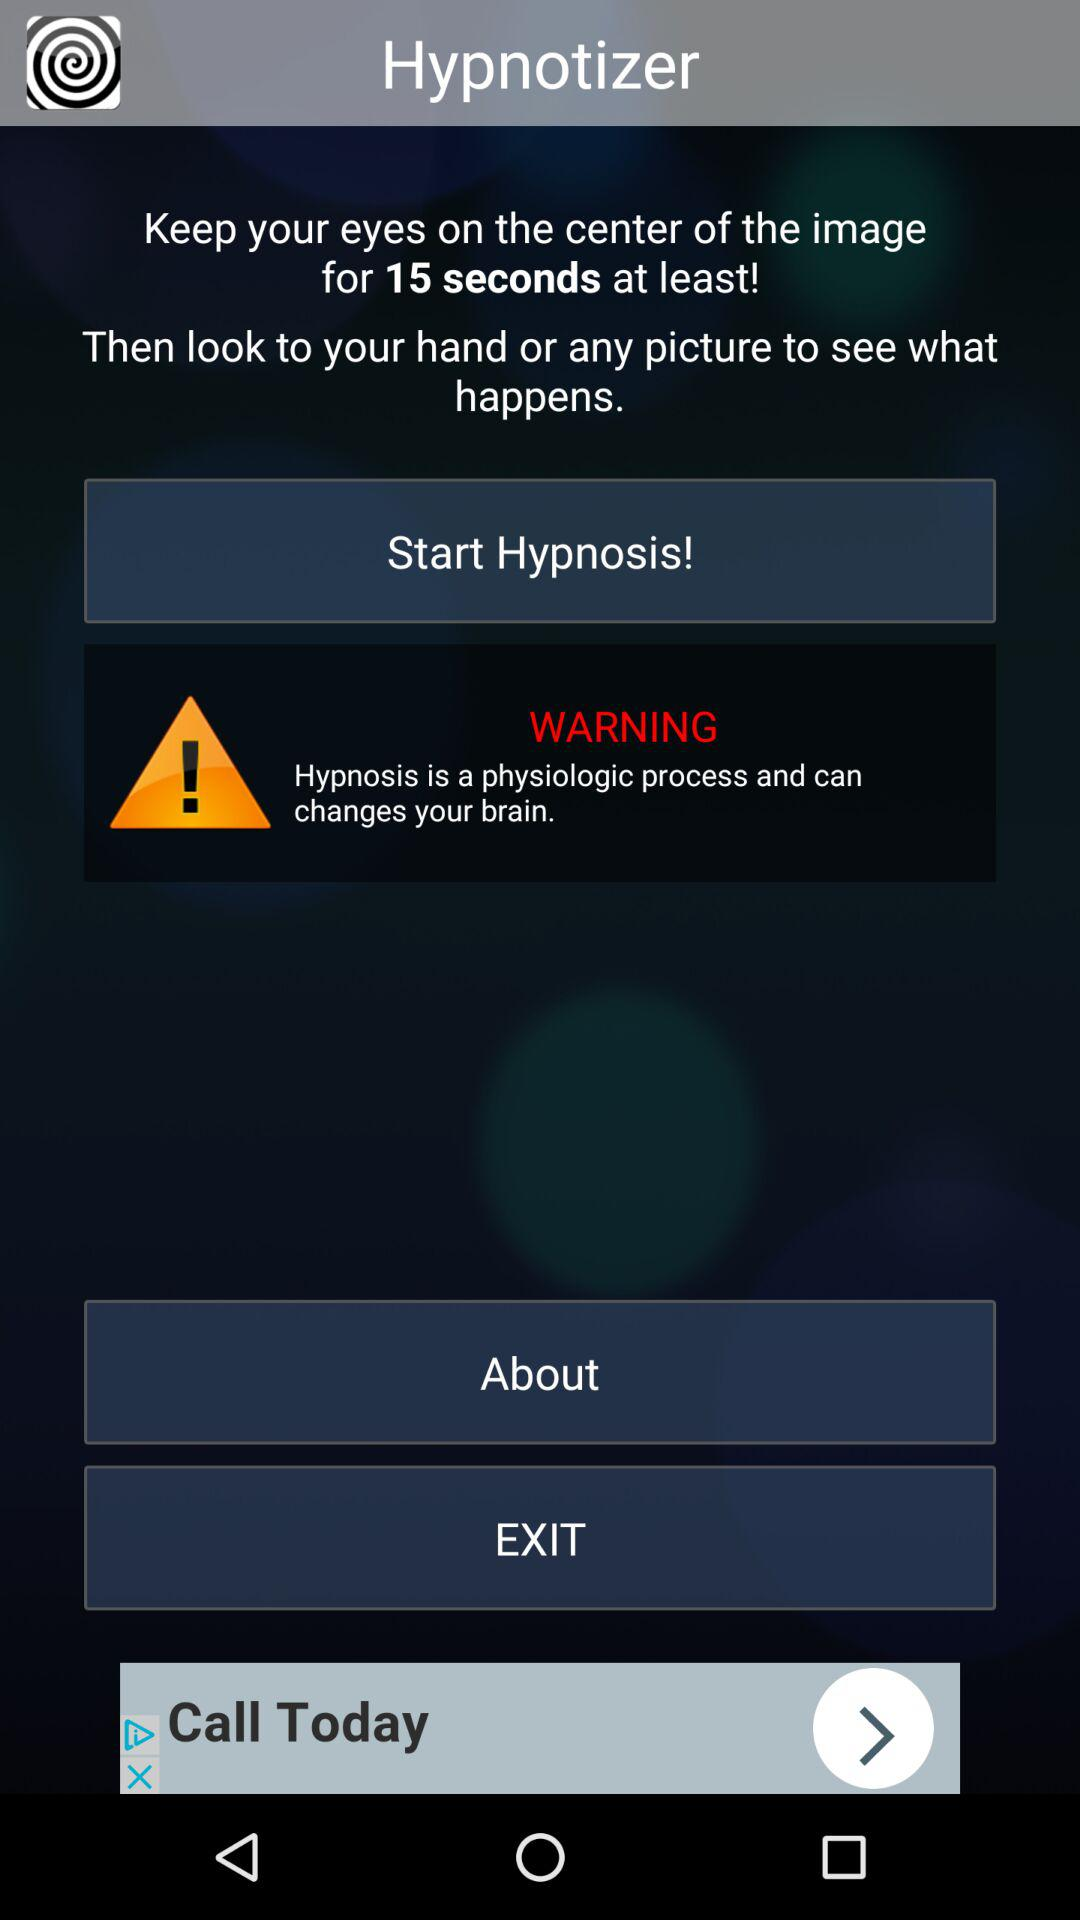What message is displayed as a warning? The message is "Hypnosis is a physiologic process and can changes your brain.". 